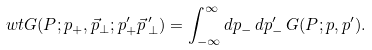Convert formula to latex. <formula><loc_0><loc_0><loc_500><loc_500>\ w t G ( P ; p _ { + } , \vec { p } _ { \bot } ; p _ { + } ^ { \prime } \vec { p } { \, } _ { \bot } ^ { \prime } ) = \int _ { - \infty } ^ { \infty } d p _ { - } \, d p _ { - } ^ { \prime } \, G ( P ; p , p ^ { \prime } ) .</formula> 